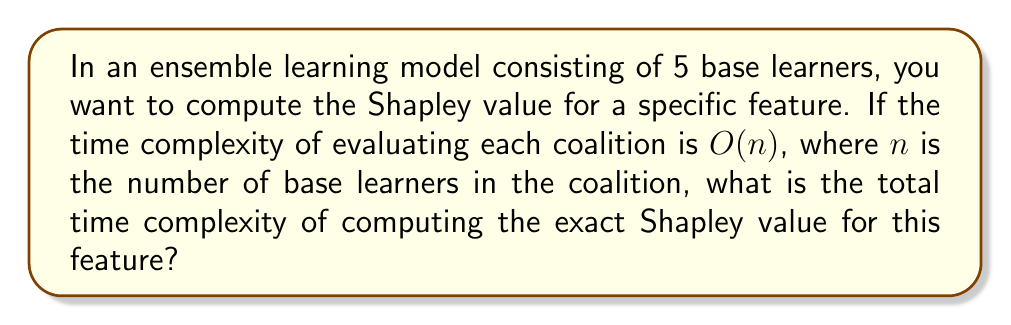Could you help me with this problem? Let's approach this step-by-step:

1) First, recall that the Shapley value requires evaluating all possible coalitions of base learners. For an ensemble with $N$ base learners, there are $2^N$ possible coalitions.

2) In this case, $N = 5$, so there are $2^5 = 32$ coalitions to evaluate.

3) The time complexity of evaluating each coalition is given as $O(n)$, where $n$ is the number of base learners in the coalition.

4) To compute the exact Shapley value, we need to evaluate all coalitions. The number of base learners in these coalitions ranges from 0 to 5.

5) Let's count the number of coalitions for each size:
   - 0 base learners: $\binom{5}{0} = 1$ coalition
   - 1 base learner:  $\binom{5}{1} = 5$ coalitions
   - 2 base learners: $\binom{5}{2} = 10$ coalitions
   - 3 base learners: $\binom{5}{3} = 10$ coalitions
   - 4 base learners: $\binom{5}{4} = 5$ coalitions
   - 5 base learners: $\binom{5}{5} = 1$ coalition

6) The total time complexity will be the sum of evaluating each of these coalitions:

   $$T = O(0) + 5O(1) + 10O(2) + 10O(3) + 5O(4) + O(5)$$

7) Simplifying:

   $$T = O(5 + 20 + 30 + 20 + 5) = O(80)$$

8) This is a constant with respect to the number of base learners, so we can express it as:

   $$T = O(1)$$

However, it's important to note that this constant-time complexity is specific to the case of 5 base learners. In general, for $N$ base learners, the time complexity would be $O(N2^N)$.
Answer: $O(1)$ 